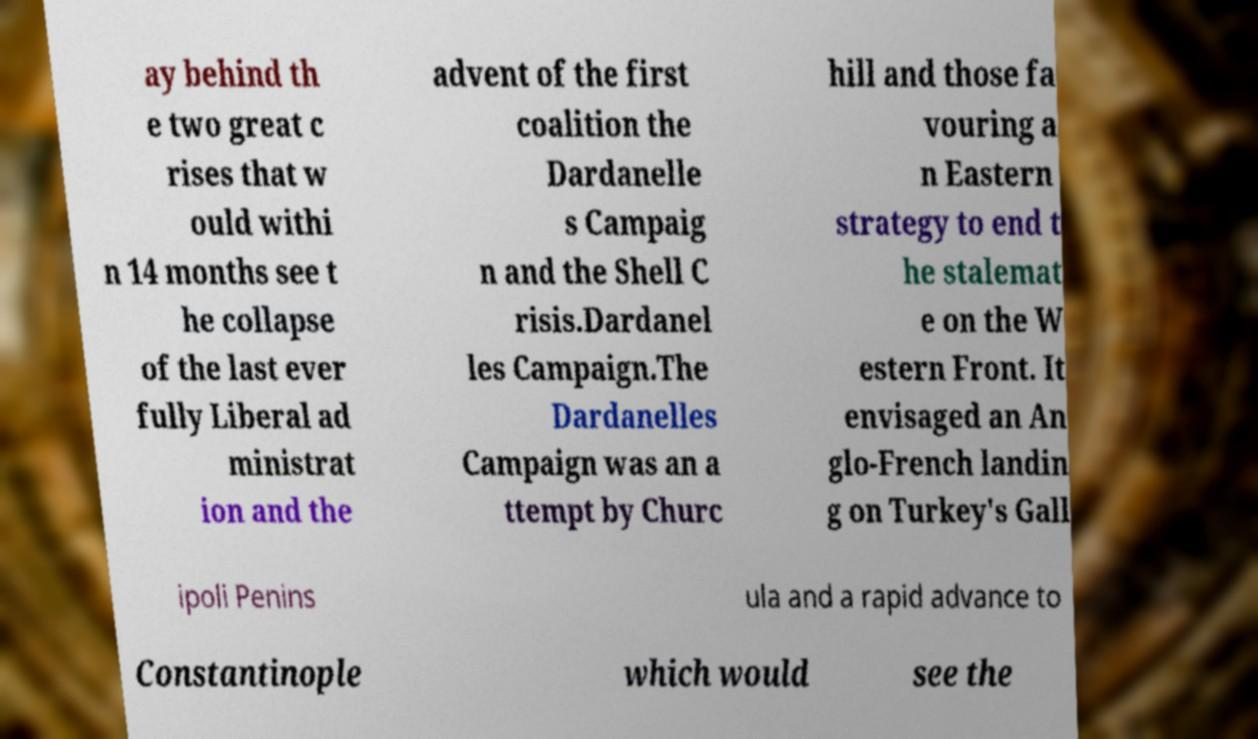Can you accurately transcribe the text from the provided image for me? ay behind th e two great c rises that w ould withi n 14 months see t he collapse of the last ever fully Liberal ad ministrat ion and the advent of the first coalition the Dardanelle s Campaig n and the Shell C risis.Dardanel les Campaign.The Dardanelles Campaign was an a ttempt by Churc hill and those fa vouring a n Eastern strategy to end t he stalemat e on the W estern Front. It envisaged an An glo-French landin g on Turkey's Gall ipoli Penins ula and a rapid advance to Constantinople which would see the 